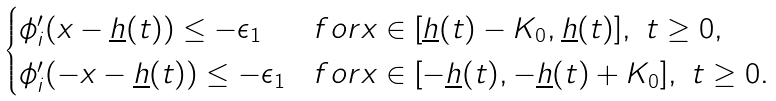Convert formula to latex. <formula><loc_0><loc_0><loc_500><loc_500>\begin{cases} \phi _ { i } ^ { \prime } ( x - \underline { h } ( t ) ) \leq - \epsilon _ { 1 } & f o r x \in [ \underline { h } ( t ) - K _ { 0 } , \underline { h } ( t ) ] , \ t \geq 0 , \\ \phi _ { i } ^ { \prime } ( - x - \underline { h } ( t ) ) \leq - \epsilon _ { 1 } & f o r x \in [ - \underline { h } ( t ) , - \underline { h } ( t ) + K _ { 0 } ] , \ t \geq 0 . \end{cases}</formula> 